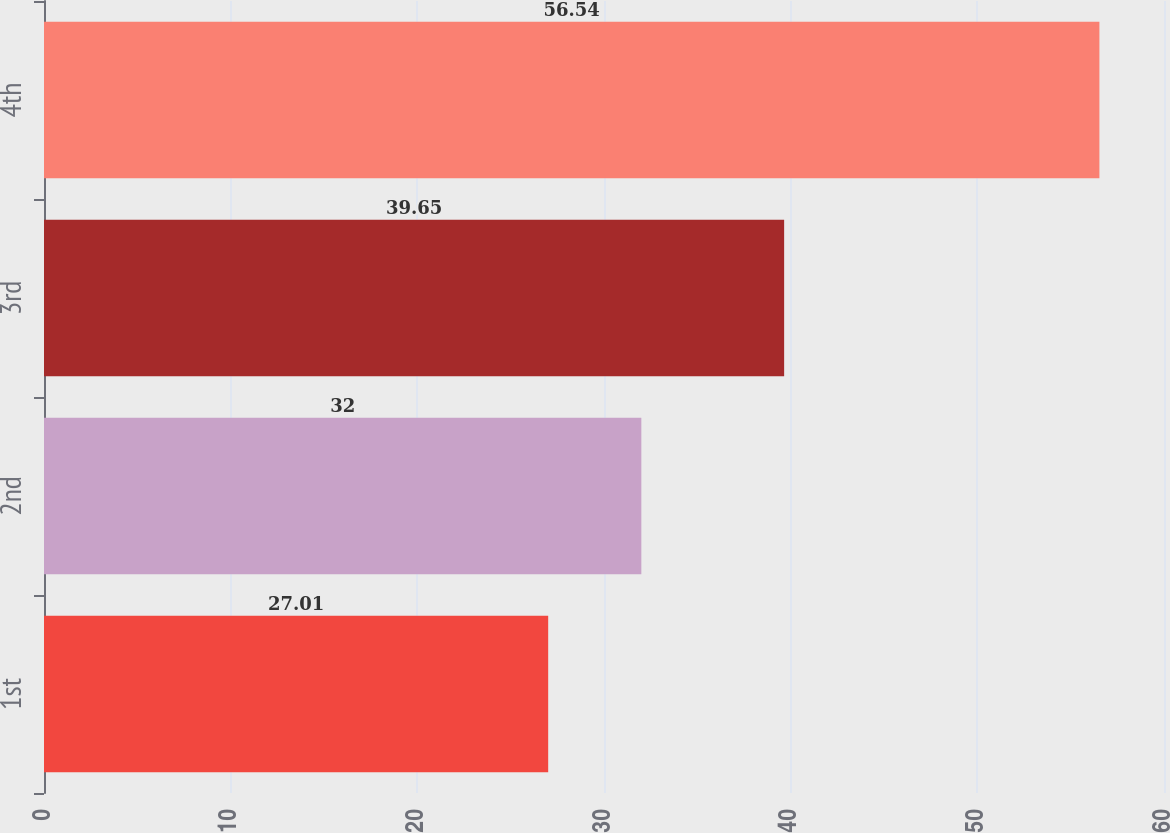Convert chart. <chart><loc_0><loc_0><loc_500><loc_500><bar_chart><fcel>1st<fcel>2nd<fcel>3rd<fcel>4th<nl><fcel>27.01<fcel>32<fcel>39.65<fcel>56.54<nl></chart> 